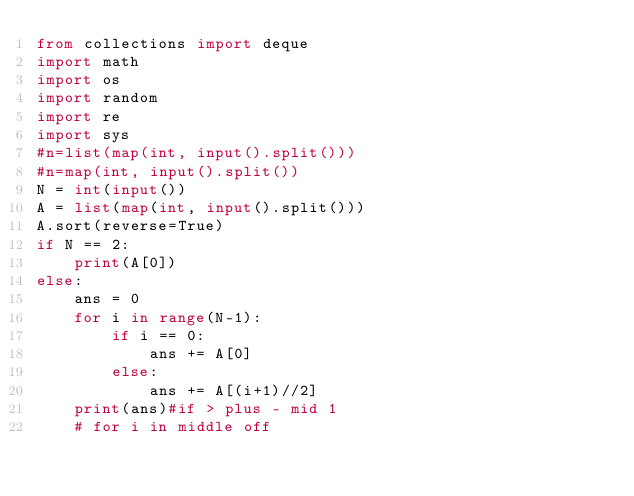Convert code to text. <code><loc_0><loc_0><loc_500><loc_500><_Python_>from collections import deque
import math
import os
import random
import re
import sys
#n=list(map(int, input().split()))
#n=map(int, input().split())
N = int(input())
A = list(map(int, input().split()))
A.sort(reverse=True)
if N == 2:
    print(A[0])
else:
    ans = 0
    for i in range(N-1):
        if i == 0:
            ans += A[0]
        else:
            ans += A[(i+1)//2]
    print(ans)#if > plus - mid 1 
    # for i in middle off</code> 